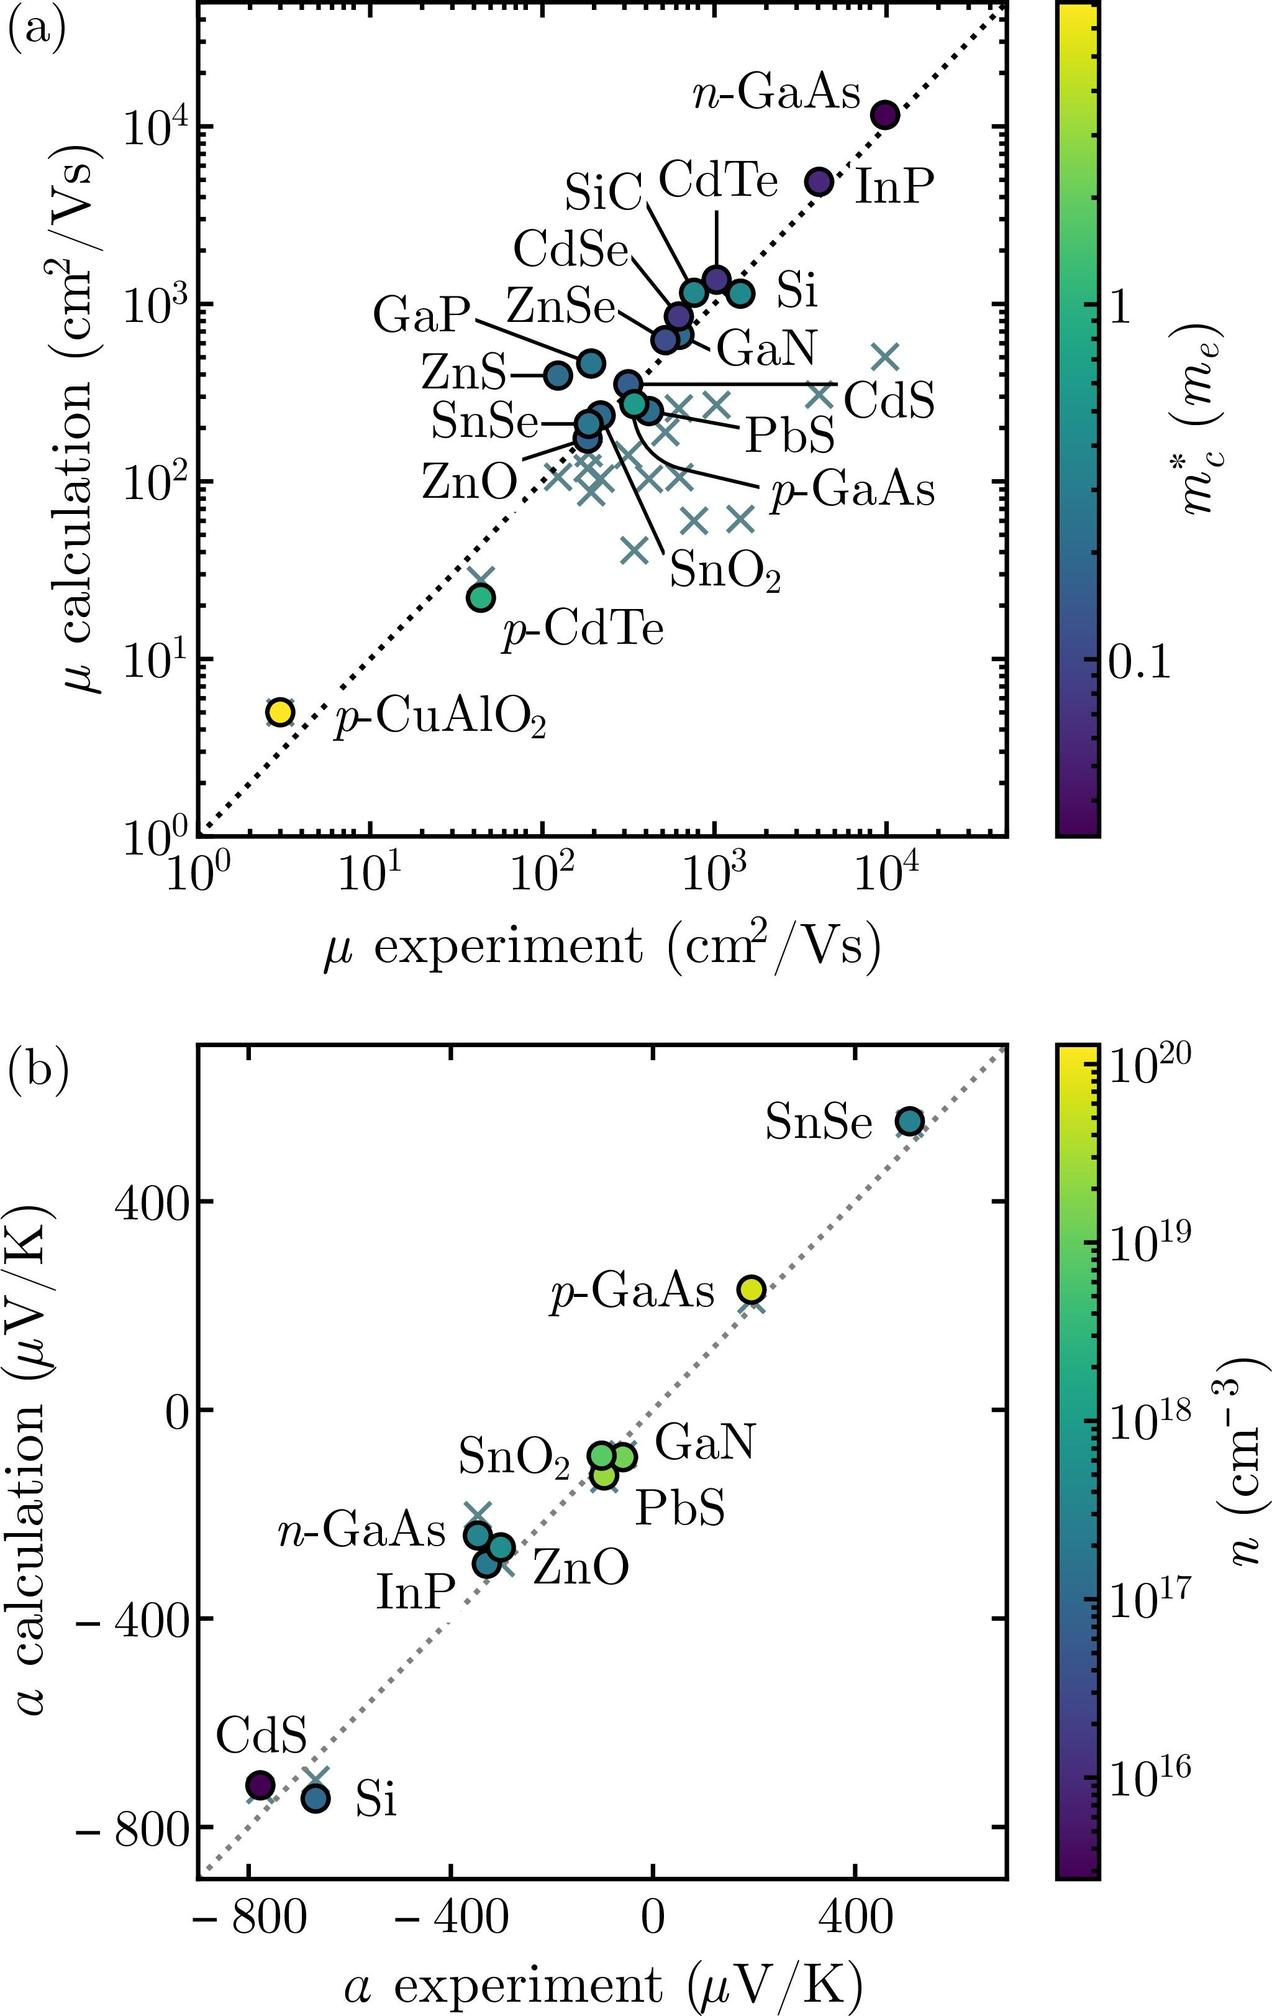According to Figure (b), what is the approximate Seebeck coefficient (α experiment) for CdS? A) \( -600 \ \mu V/K \) B) \( -200 \ \mu V/K \) C) \( 200 \ \mu V/K \) D) \( 600 \ \mu V/K \) In Figure (b), the Seebeck coefficient for various materials is plotted, with CdS located at the far left side of the plot, indicating a negative Seebeck coefficient of approximately \( -600 \ \mu V/K \). Therefore, the correct answer is A) \( -600 \ \mu V/K \). 